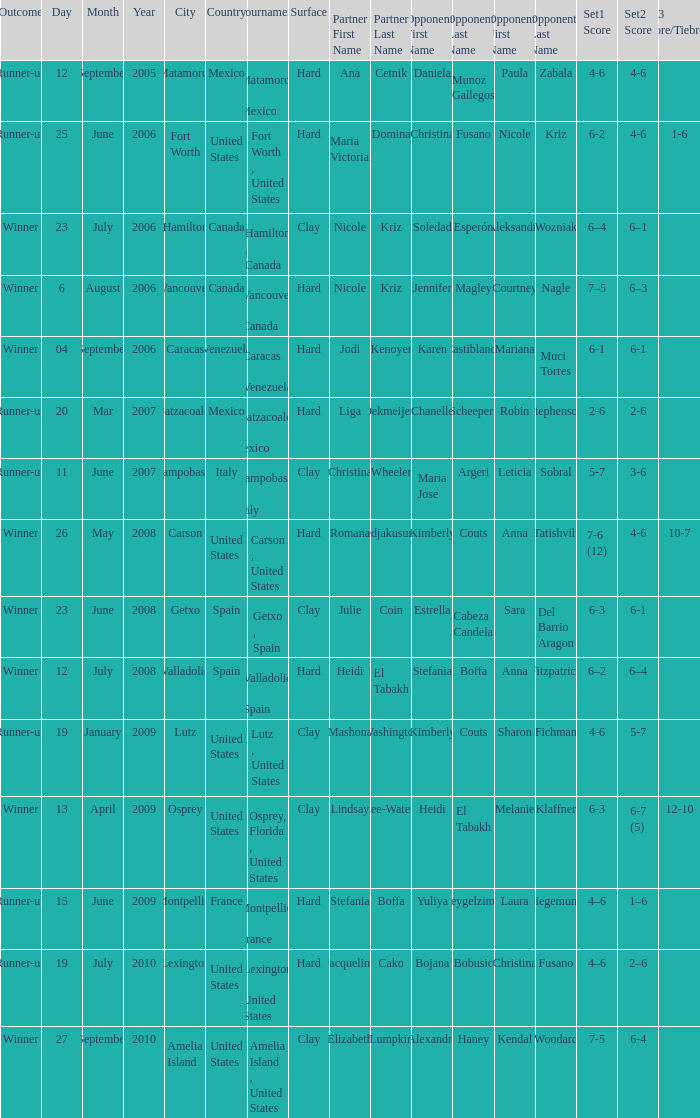Who were the opponents during the final when christina wheeler was partner? Maria Jose Argeri Leticia Sobral. 